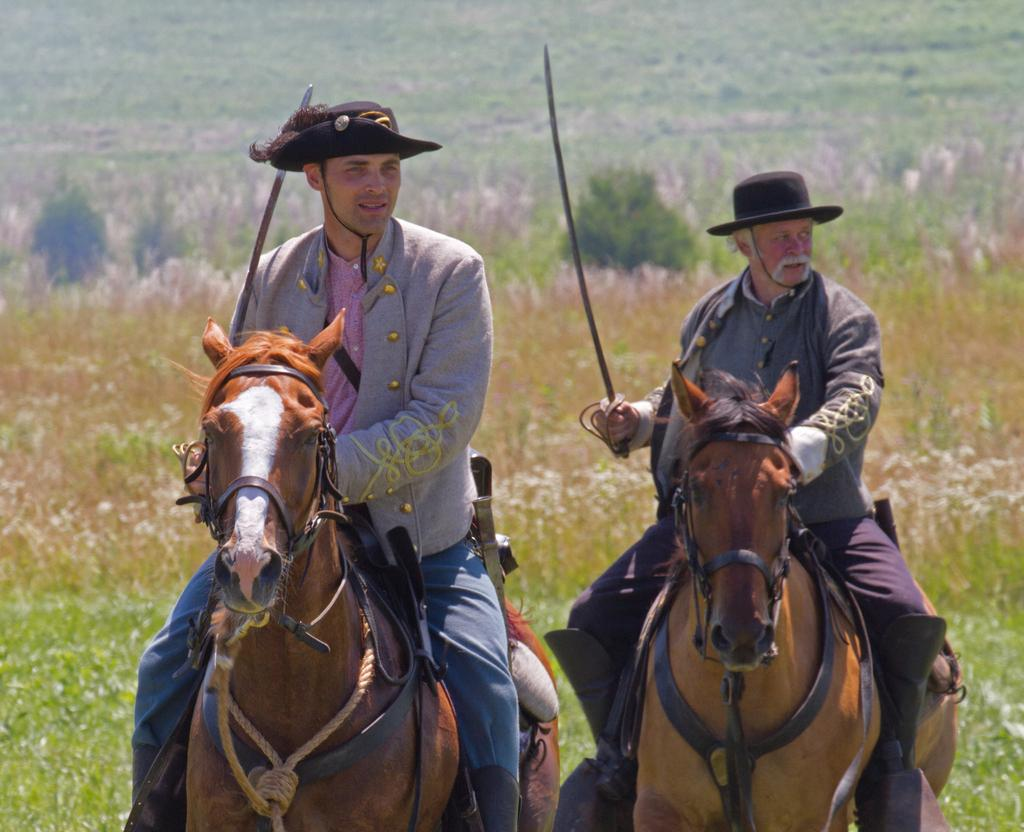Where is the location of the image? The image is outside of the city. How many people are in the image? There are two men in the image. What are the men doing in the image? The men are sitting on horses and riding them. What can be seen in the background of the image? There are plants and trees in the background of the image. What type of marble is visible on the horses' bodies in the image? There is no marble visible on the horses' bodies in the image. The horses are not made of marble; they are real horses being ridden by the men. 